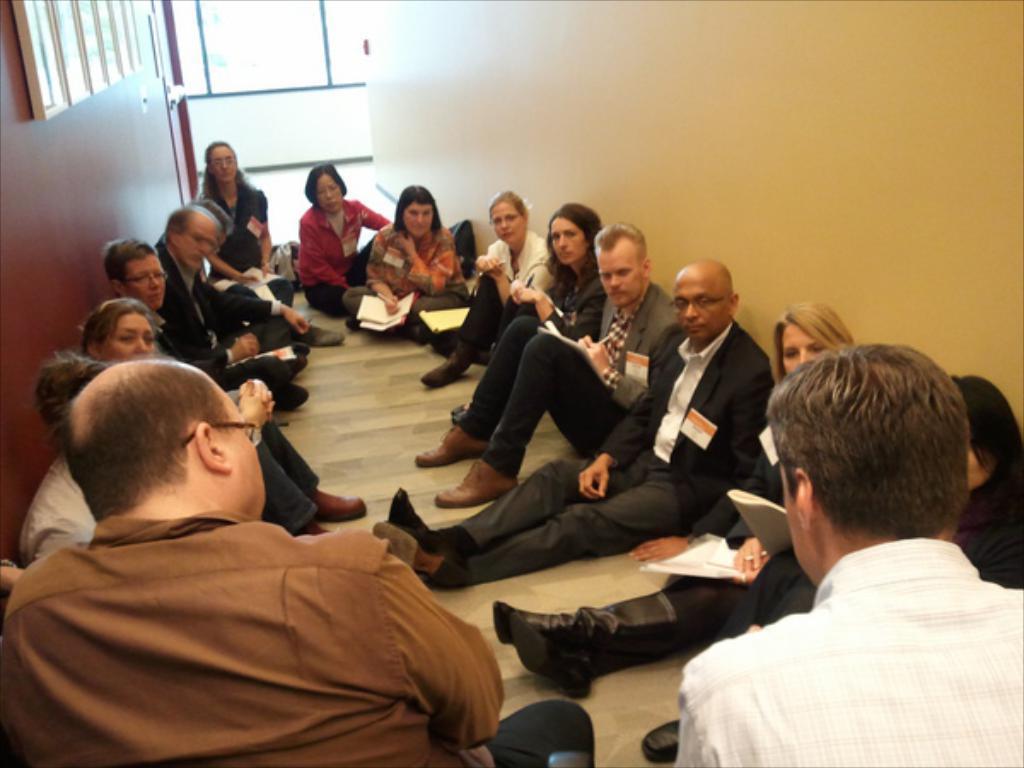Please provide a concise description of this image. In the image there are few people sitting on the floor. And they are holding a few papers and books in their hands. And also there are cards on their jackets. Behind them there are walls with windows and doors. 